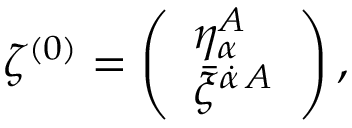<formula> <loc_0><loc_0><loc_500><loc_500>{ \zeta ^ { ( 0 ) } = \left ( \begin{array} { l } { { \eta _ { \alpha } ^ { A } } } \\ { { \bar { \xi } ^ { \dot { \alpha } \, A } } } \end{array} \right ) , }</formula> 